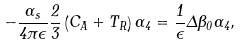Convert formula to latex. <formula><loc_0><loc_0><loc_500><loc_500>- \frac { \alpha _ { s } } { 4 \pi \epsilon } \frac { 2 } { 3 } \left ( C _ { A } + T _ { R } \right ) \Gamma _ { 4 } = \frac { 1 } { \epsilon } \Delta \beta _ { 0 } \Gamma _ { 4 } ,</formula> 